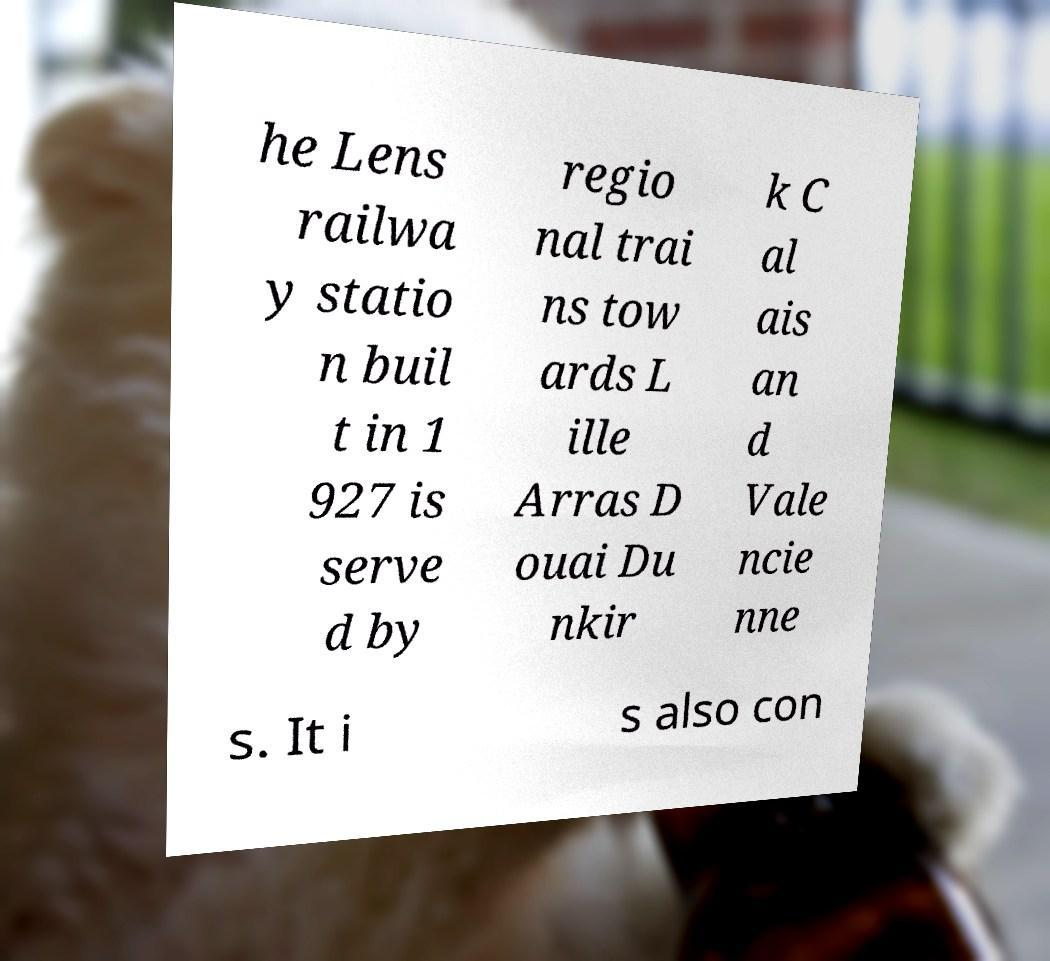Could you assist in decoding the text presented in this image and type it out clearly? he Lens railwa y statio n buil t in 1 927 is serve d by regio nal trai ns tow ards L ille Arras D ouai Du nkir k C al ais an d Vale ncie nne s. It i s also con 